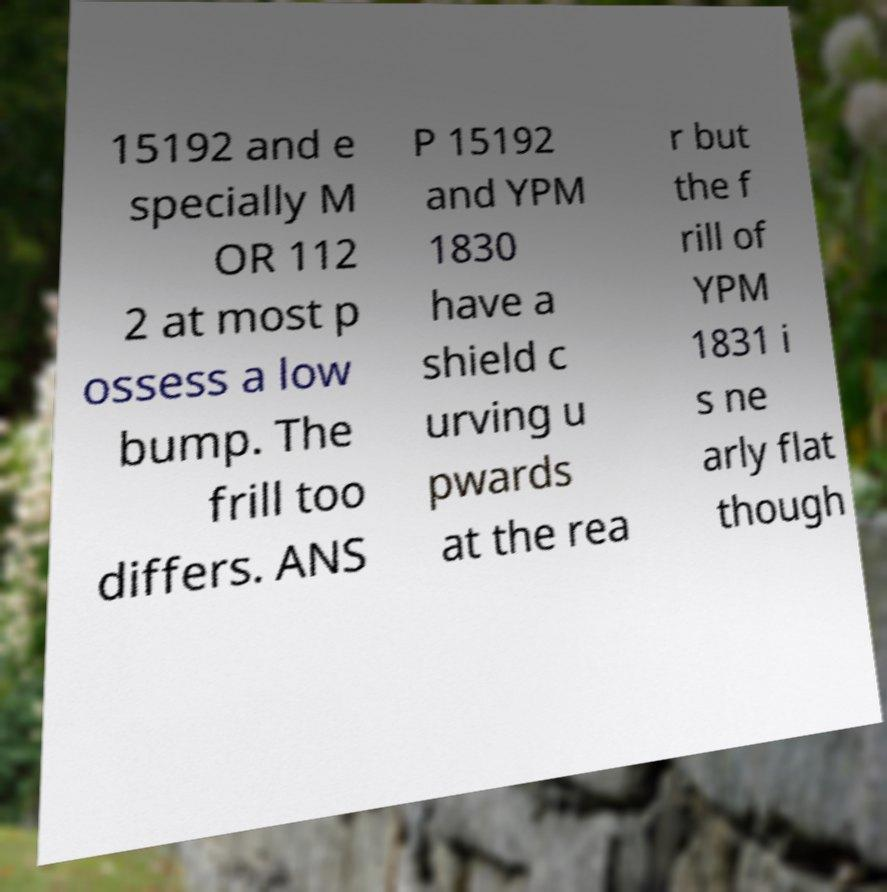Can you read and provide the text displayed in the image?This photo seems to have some interesting text. Can you extract and type it out for me? 15192 and e specially M OR 112 2 at most p ossess a low bump. The frill too differs. ANS P 15192 and YPM 1830 have a shield c urving u pwards at the rea r but the f rill of YPM 1831 i s ne arly flat though 